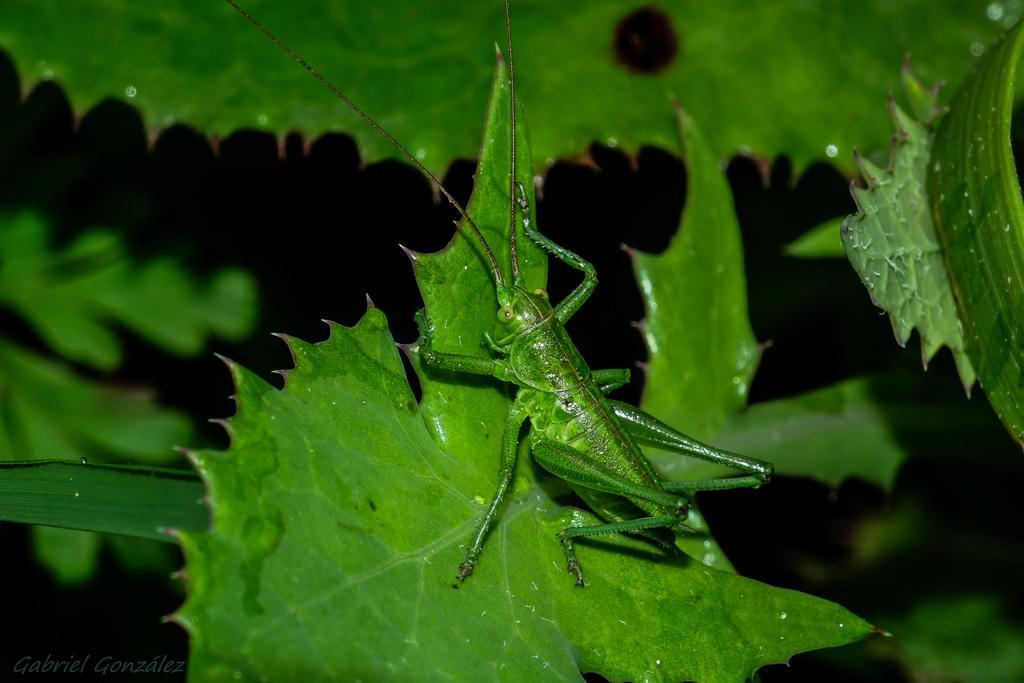Please provide a concise description of this image. In the picture I can see an insect on the green leaf. 